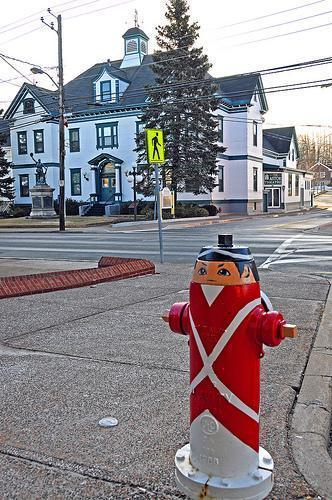How many fire hydrants are pictured?
Give a very brief answer. 1. 